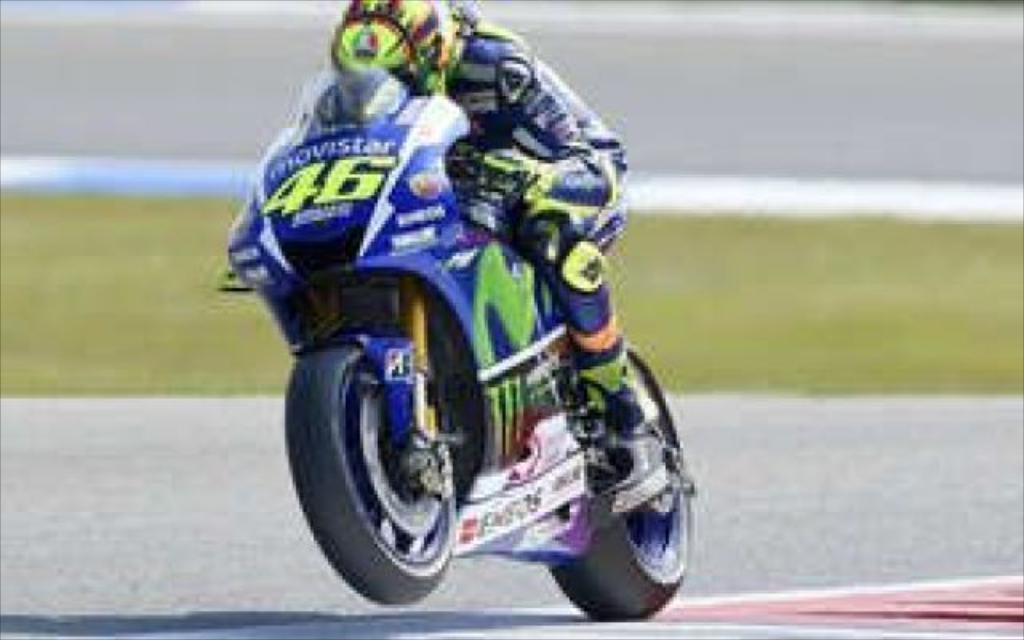In one or two sentences, can you explain what this image depicts? In this picture we can see a person is riding motorcycle on the road, in the background we can see grass. 